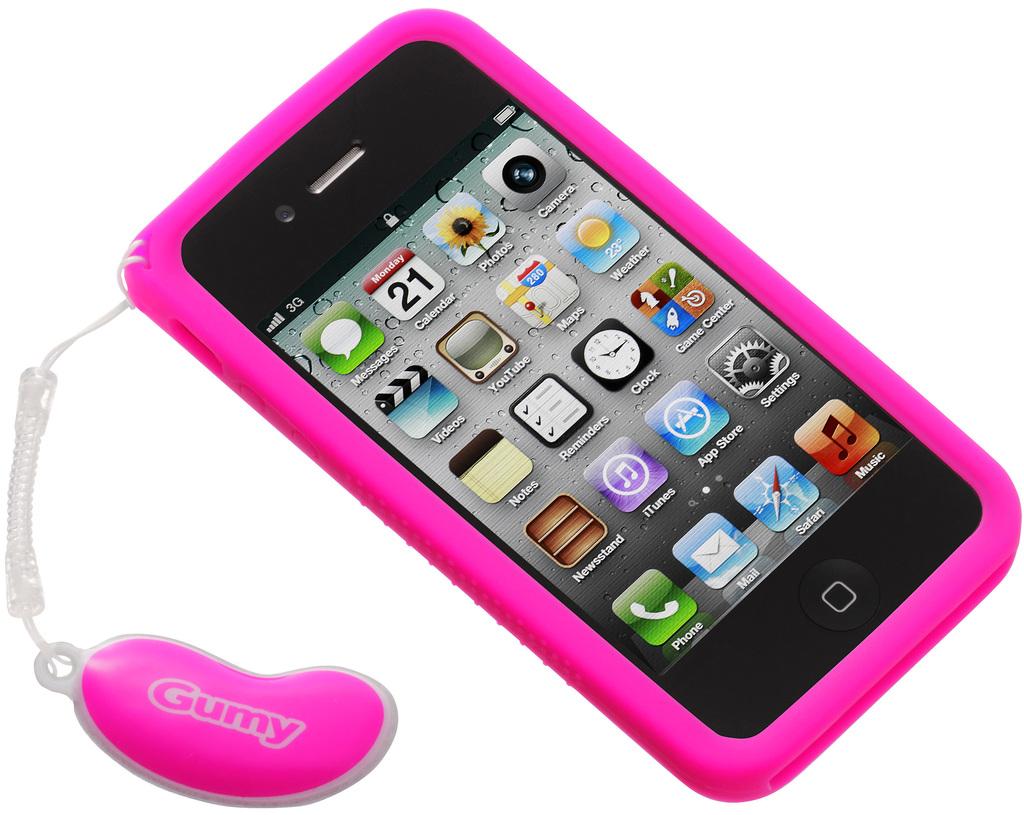What brand is the phone case?
Offer a very short reply. Gumy. What does the app in the top left corner say?
Keep it short and to the point. Messages. 